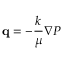Convert formula to latex. <formula><loc_0><loc_0><loc_500><loc_500>{ q } = - \frac { k } { \mu } \nabla P</formula> 